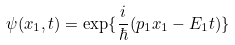<formula> <loc_0><loc_0><loc_500><loc_500>\psi ( x _ { 1 } , t ) = \exp \{ \frac { i } { \hbar } { ( } p _ { 1 } x _ { 1 } - E _ { 1 } t ) \}</formula> 